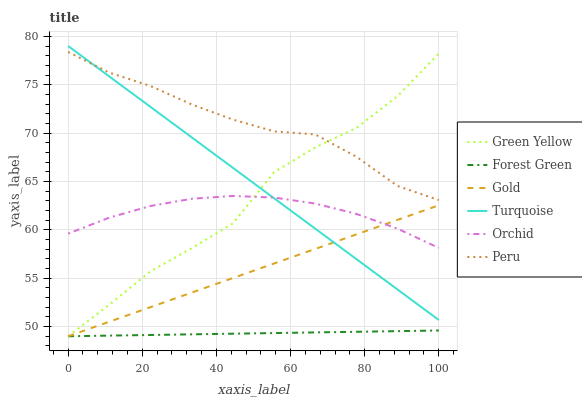Does Forest Green have the minimum area under the curve?
Answer yes or no. Yes. Does Peru have the maximum area under the curve?
Answer yes or no. Yes. Does Gold have the minimum area under the curve?
Answer yes or no. No. Does Gold have the maximum area under the curve?
Answer yes or no. No. Is Gold the smoothest?
Answer yes or no. Yes. Is Green Yellow the roughest?
Answer yes or no. Yes. Is Forest Green the smoothest?
Answer yes or no. No. Is Forest Green the roughest?
Answer yes or no. No. Does Peru have the lowest value?
Answer yes or no. No. Does Turquoise have the highest value?
Answer yes or no. Yes. Does Gold have the highest value?
Answer yes or no. No. Is Forest Green less than Peru?
Answer yes or no. Yes. Is Orchid greater than Forest Green?
Answer yes or no. Yes. Does Orchid intersect Turquoise?
Answer yes or no. Yes. Is Orchid less than Turquoise?
Answer yes or no. No. Is Orchid greater than Turquoise?
Answer yes or no. No. Does Forest Green intersect Peru?
Answer yes or no. No. 